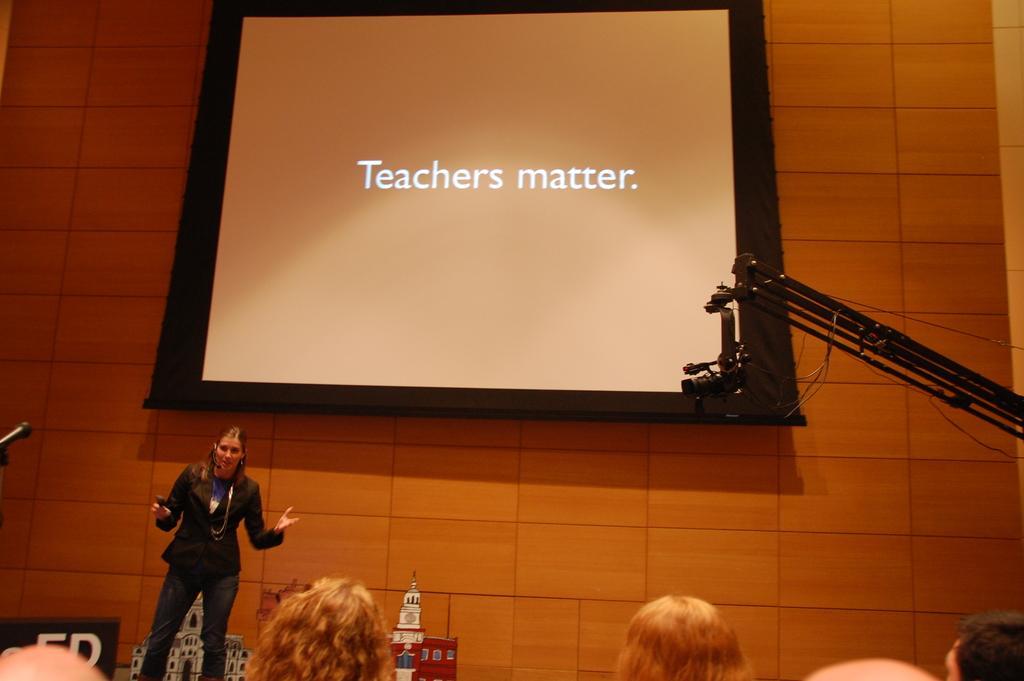Could you give a brief overview of what you see in this image? In this picture I can see few persons heads in front and in the middle of this picture, I can see a woman standing and holding a thing. On the top side of this picture I can see a projector screen and I see something is written on it. On the right side of this picture I can see an equipment and in the background I can see the wall. 